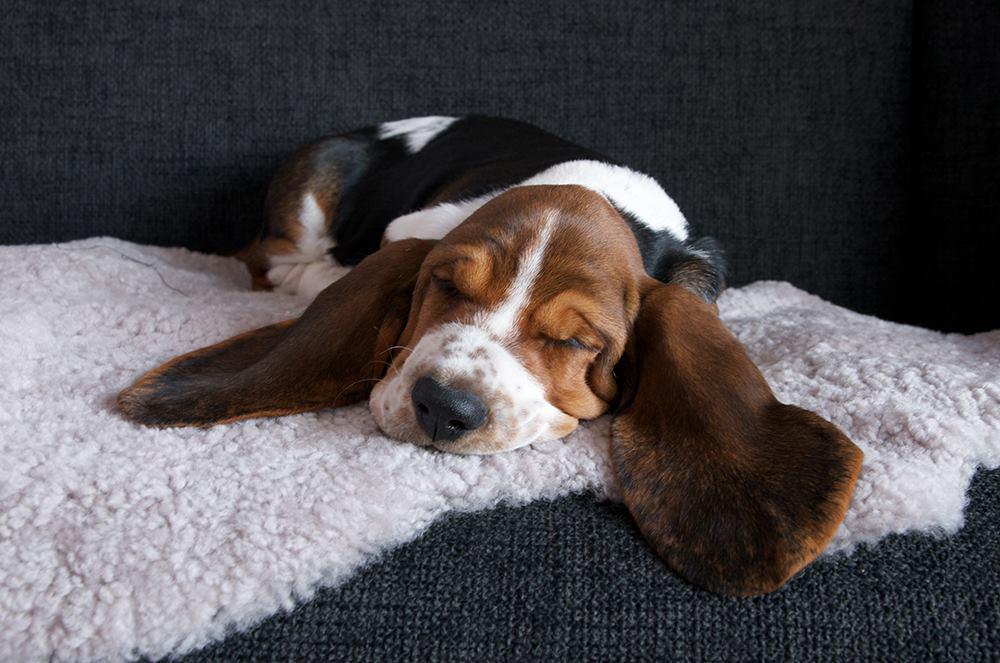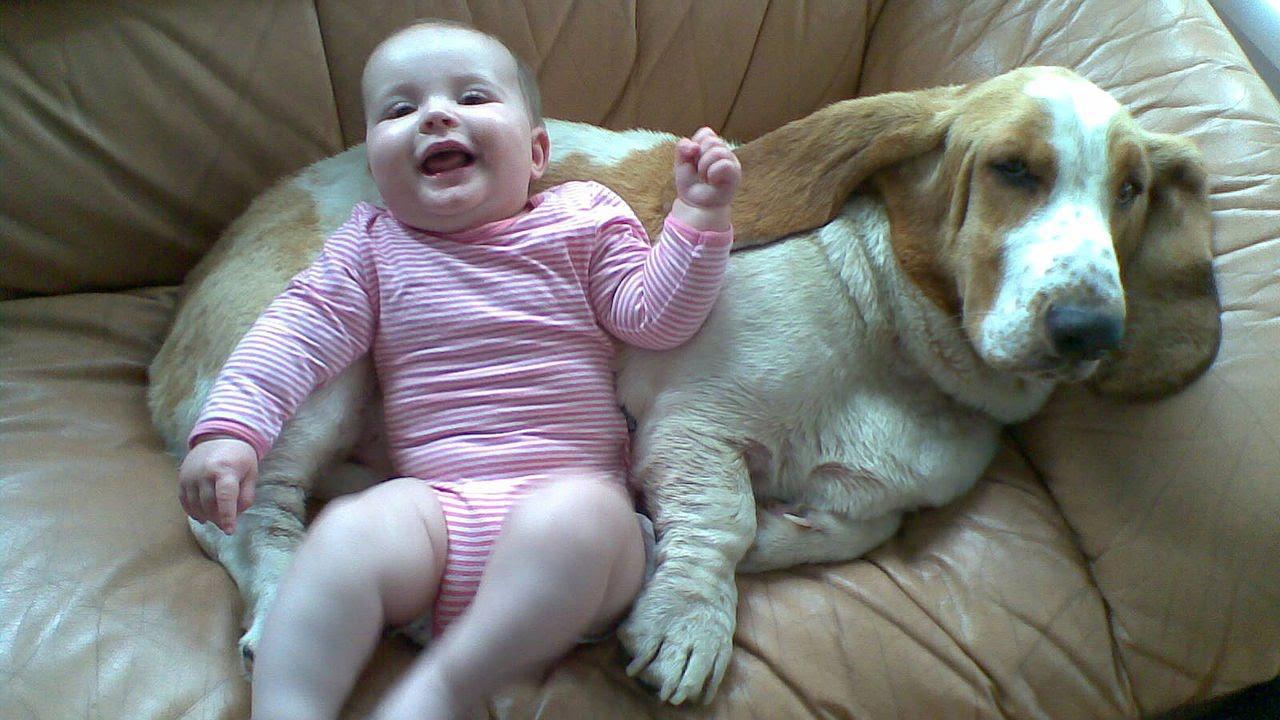The first image is the image on the left, the second image is the image on the right. Examine the images to the left and right. Is the description "There are three dogs." accurate? Answer yes or no. No. The first image is the image on the left, the second image is the image on the right. Considering the images on both sides, is "An image shows two basset hounds side-by-side outdoors, and at least one has its loose jowls flapping." valid? Answer yes or no. No. 